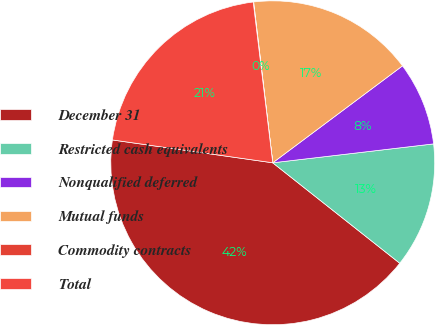<chart> <loc_0><loc_0><loc_500><loc_500><pie_chart><fcel>December 31<fcel>Restricted cash equivalents<fcel>Nonqualified deferred<fcel>Mutual funds<fcel>Commodity contracts<fcel>Total<nl><fcel>41.6%<fcel>12.51%<fcel>8.35%<fcel>16.67%<fcel>0.04%<fcel>20.82%<nl></chart> 